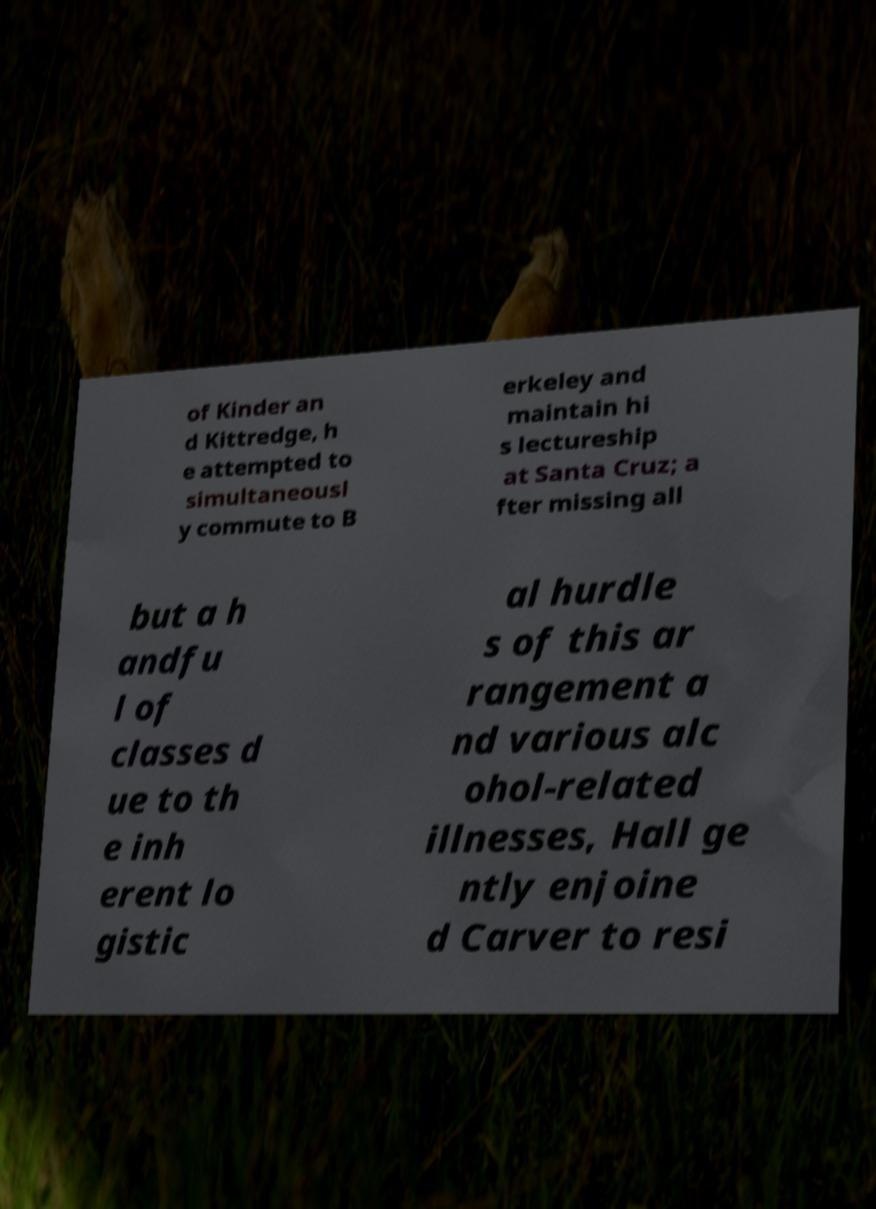I need the written content from this picture converted into text. Can you do that? of Kinder an d Kittredge, h e attempted to simultaneousl y commute to B erkeley and maintain hi s lectureship at Santa Cruz; a fter missing all but a h andfu l of classes d ue to th e inh erent lo gistic al hurdle s of this ar rangement a nd various alc ohol-related illnesses, Hall ge ntly enjoine d Carver to resi 